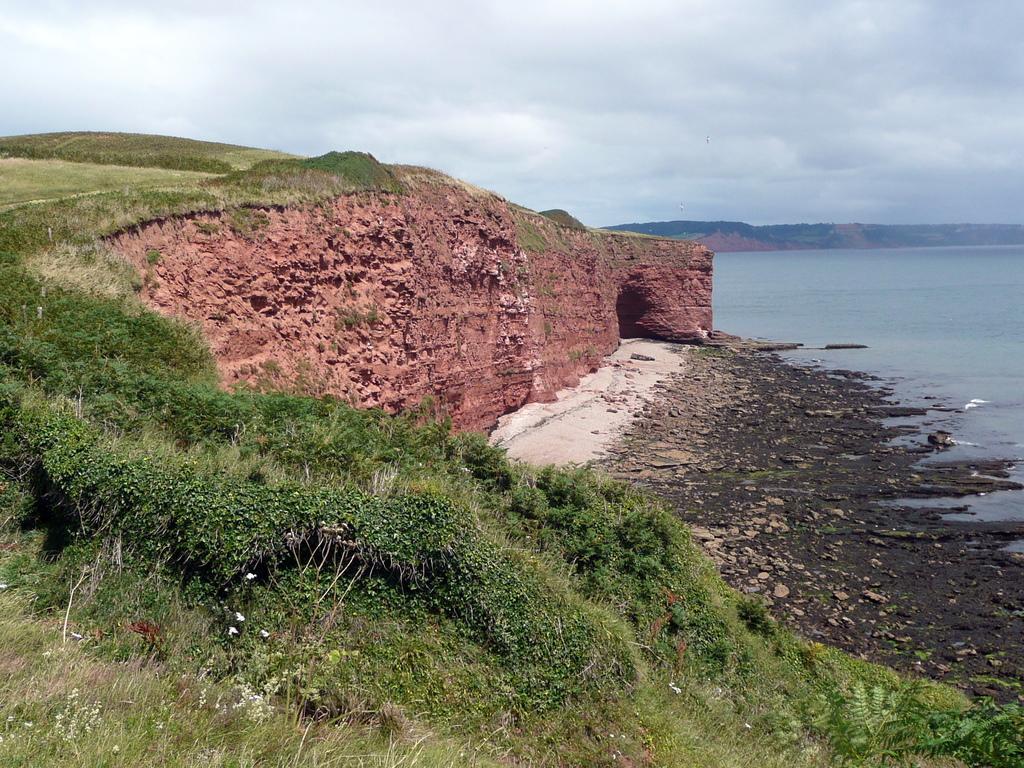In one or two sentences, can you explain what this image depicts? In this image there is a grassland, below that there is a river, in the background there is a cloudy sky. 